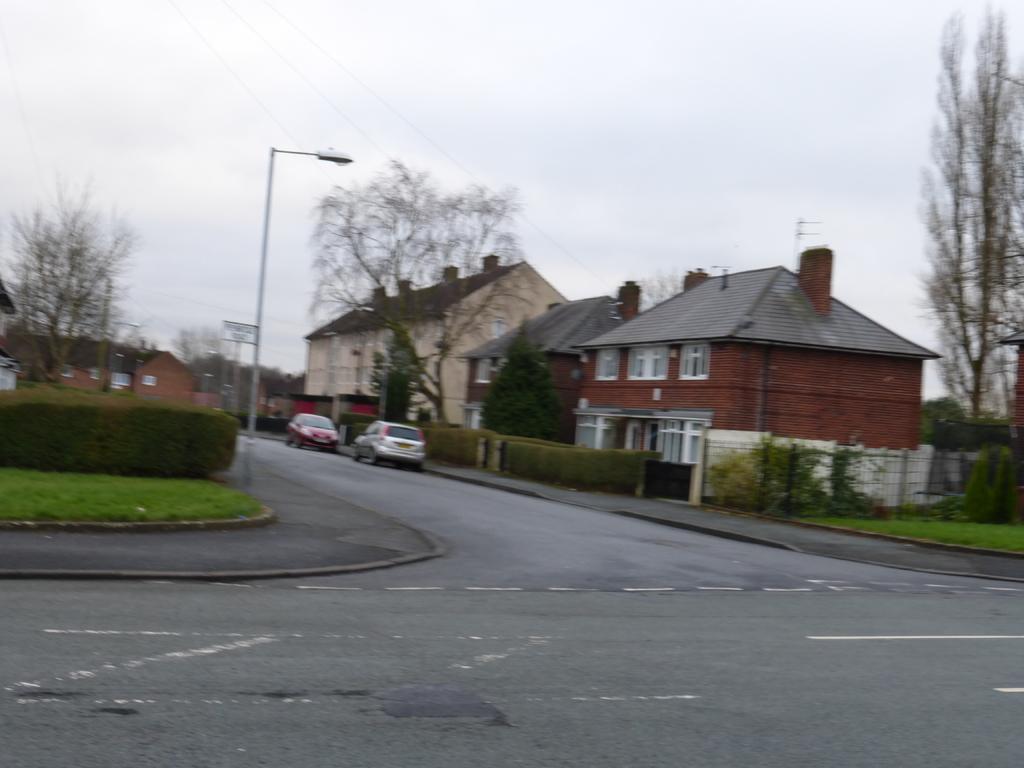Could you give a brief overview of what you see in this image? In this image we can see two cars on the road. In the background of the image, we can see dry trees, plants, grassy land, fence, street light and houses. At the top of the image, the sky is covered with clouds. 